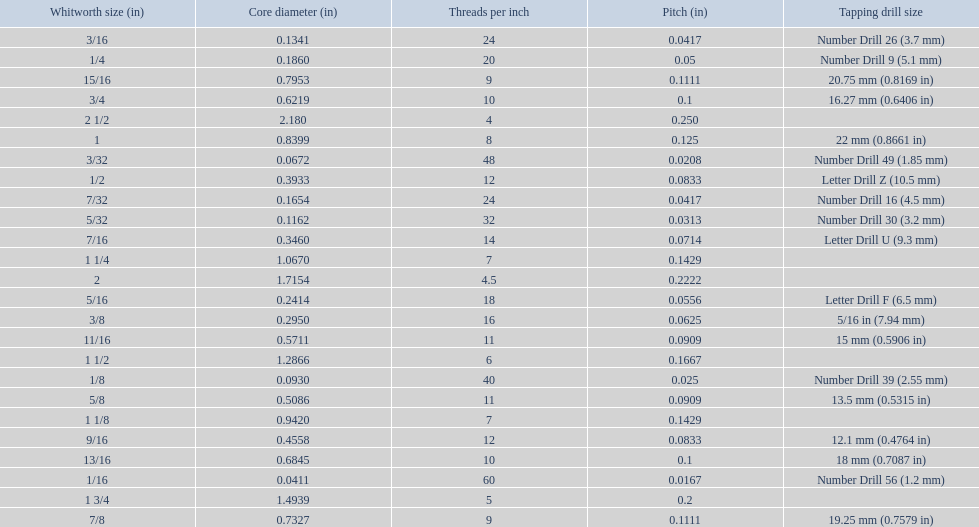What is the core diameter for the number drill 26? 0.1341. What is the whitworth size (in) for this core diameter? 3/16. 